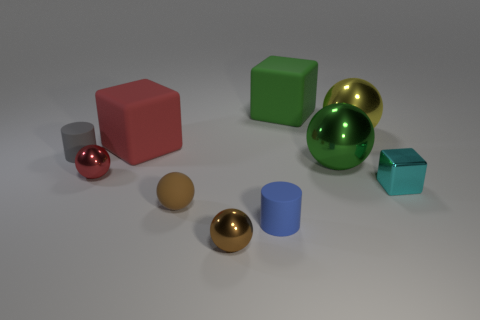Subtract all yellow spheres. How many spheres are left? 4 Subtract all green shiny balls. How many balls are left? 4 Subtract all gray spheres. Subtract all gray cylinders. How many spheres are left? 5 Subtract all cubes. How many objects are left? 7 Add 7 cyan matte cylinders. How many cyan matte cylinders exist? 7 Subtract 1 green blocks. How many objects are left? 9 Subtract all large red blocks. Subtract all metal balls. How many objects are left? 5 Add 8 small gray cylinders. How many small gray cylinders are left? 9 